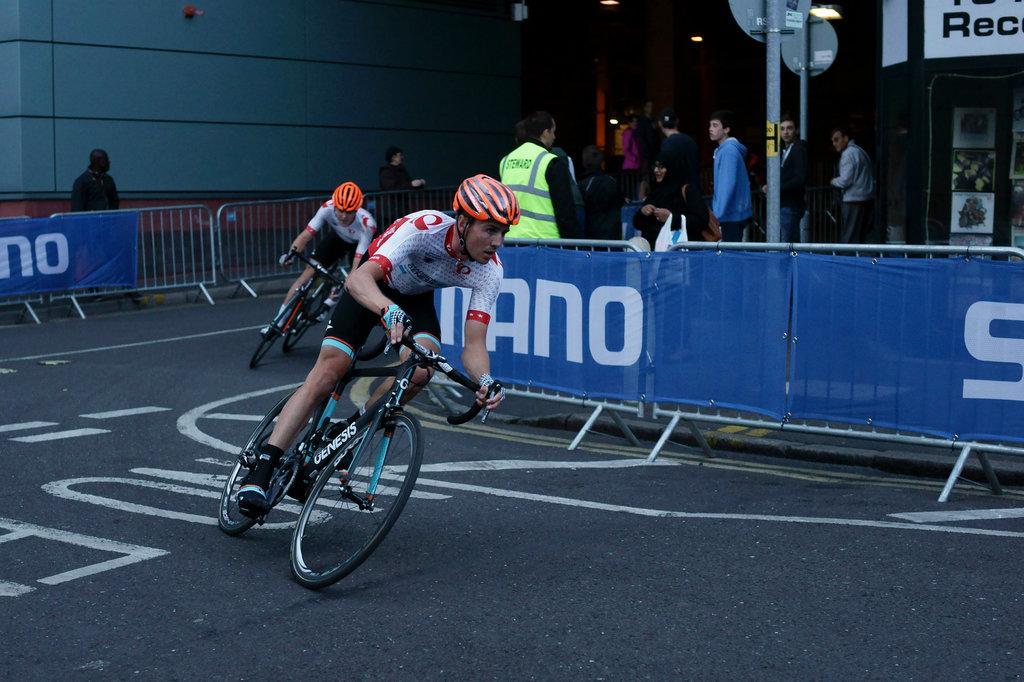Describe this image in one or two sentences. In this picture there are two persons riding motorbike on the road. There are group of people standing behind the railings and there are banners on the railings. At the back there is a building and there are boards on the poles and there is a hoarding and posters on the wall. At the top there are lights. At the bottom there is a road. 